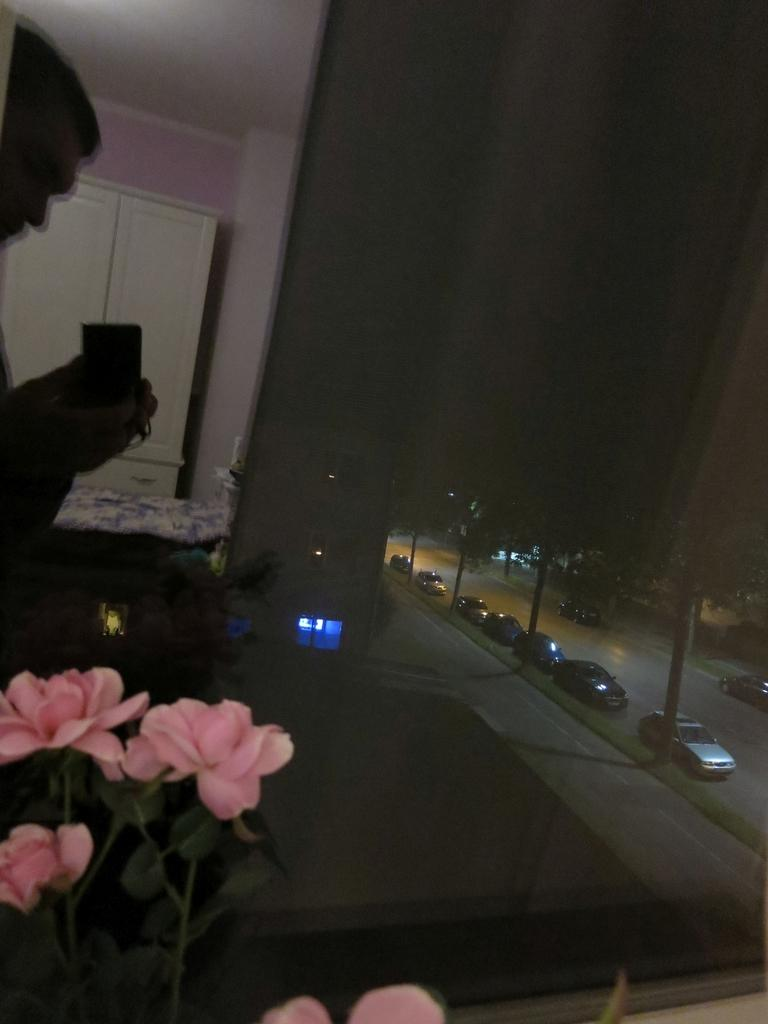What is the person holding in the image? There is a person holding an object in the image. What type of structures can be seen in the image? There are buildings in the image. What piece of furniture is present in the image? There is a cupboard in the image. What type of bed is visible in the image? There is a cot in the image. What type of plant is present in the image? There are flowers in the image. What type of transportation can be seen on the road in the image? Motor vehicles are visible on the road in the image. What type of ground cover is present in the image? Grass is present in the image. What type of lighting is visible in the image? Electric lights are visible in the image. What type of nut is being cracked on the cot in the image? There is no nut present in the image, nor is there any activity of cracking nuts on the cot. 